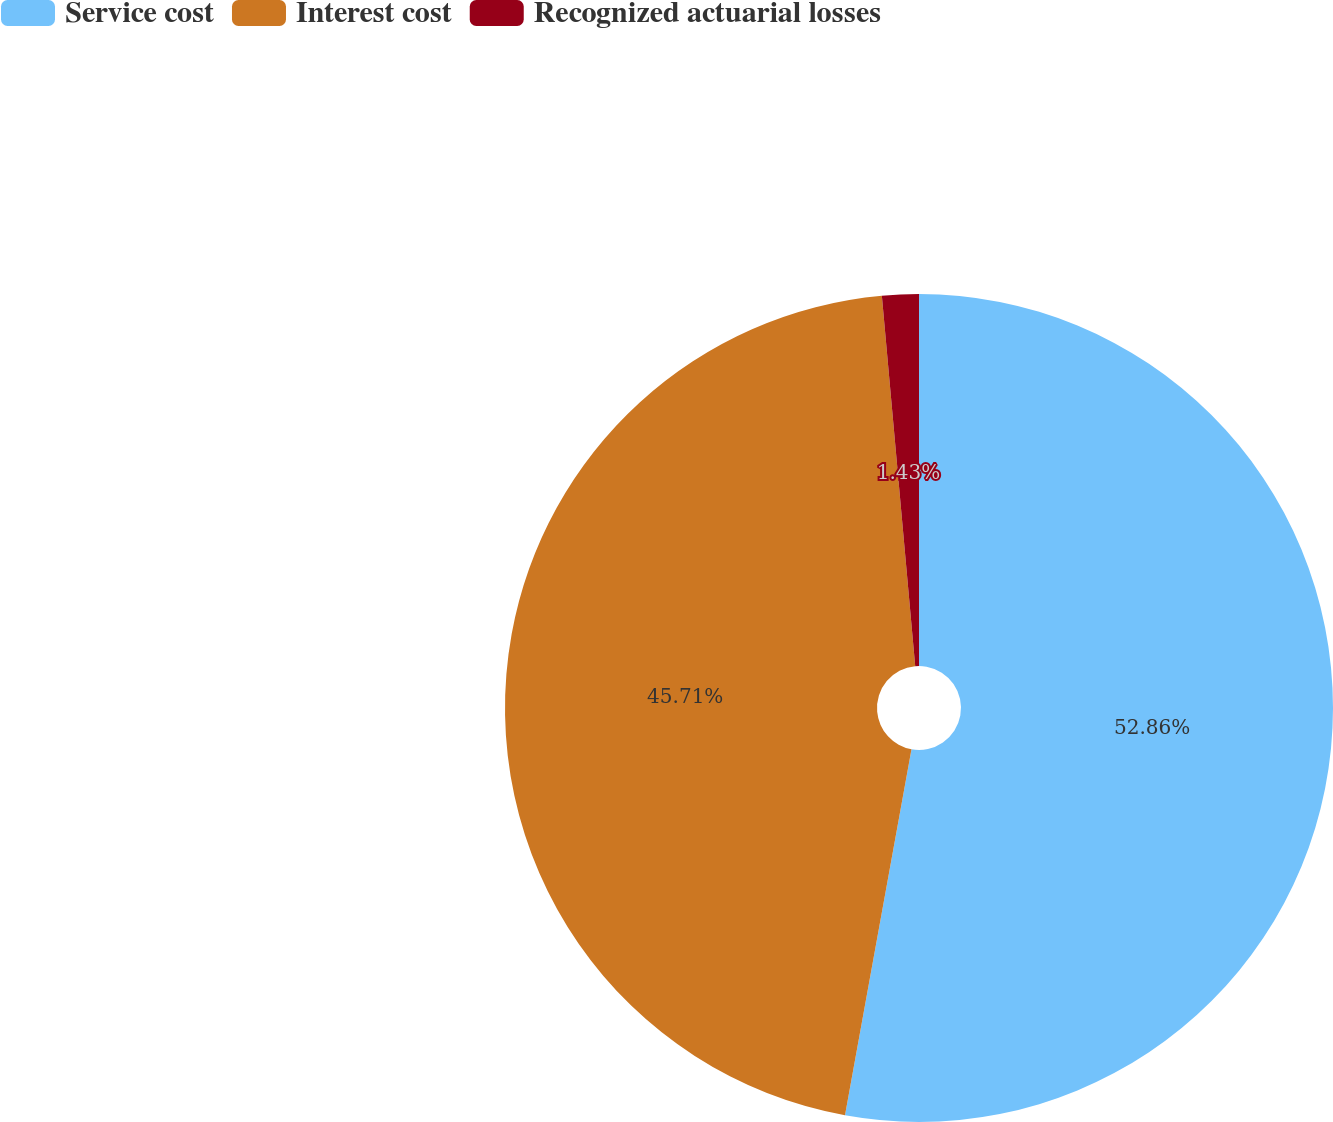Convert chart to OTSL. <chart><loc_0><loc_0><loc_500><loc_500><pie_chart><fcel>Service cost<fcel>Interest cost<fcel>Recognized actuarial losses<nl><fcel>52.86%<fcel>45.71%<fcel>1.43%<nl></chart> 